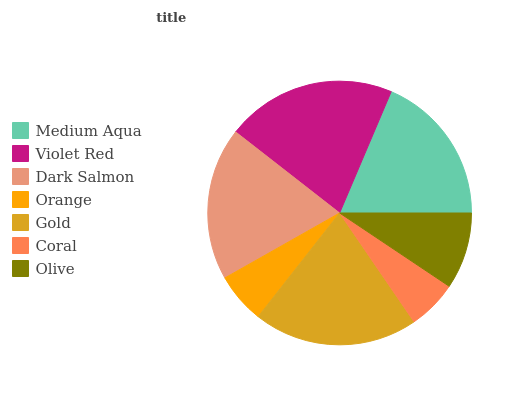Is Coral the minimum?
Answer yes or no. Yes. Is Violet Red the maximum?
Answer yes or no. Yes. Is Dark Salmon the minimum?
Answer yes or no. No. Is Dark Salmon the maximum?
Answer yes or no. No. Is Violet Red greater than Dark Salmon?
Answer yes or no. Yes. Is Dark Salmon less than Violet Red?
Answer yes or no. Yes. Is Dark Salmon greater than Violet Red?
Answer yes or no. No. Is Violet Red less than Dark Salmon?
Answer yes or no. No. Is Medium Aqua the high median?
Answer yes or no. Yes. Is Medium Aqua the low median?
Answer yes or no. Yes. Is Gold the high median?
Answer yes or no. No. Is Dark Salmon the low median?
Answer yes or no. No. 